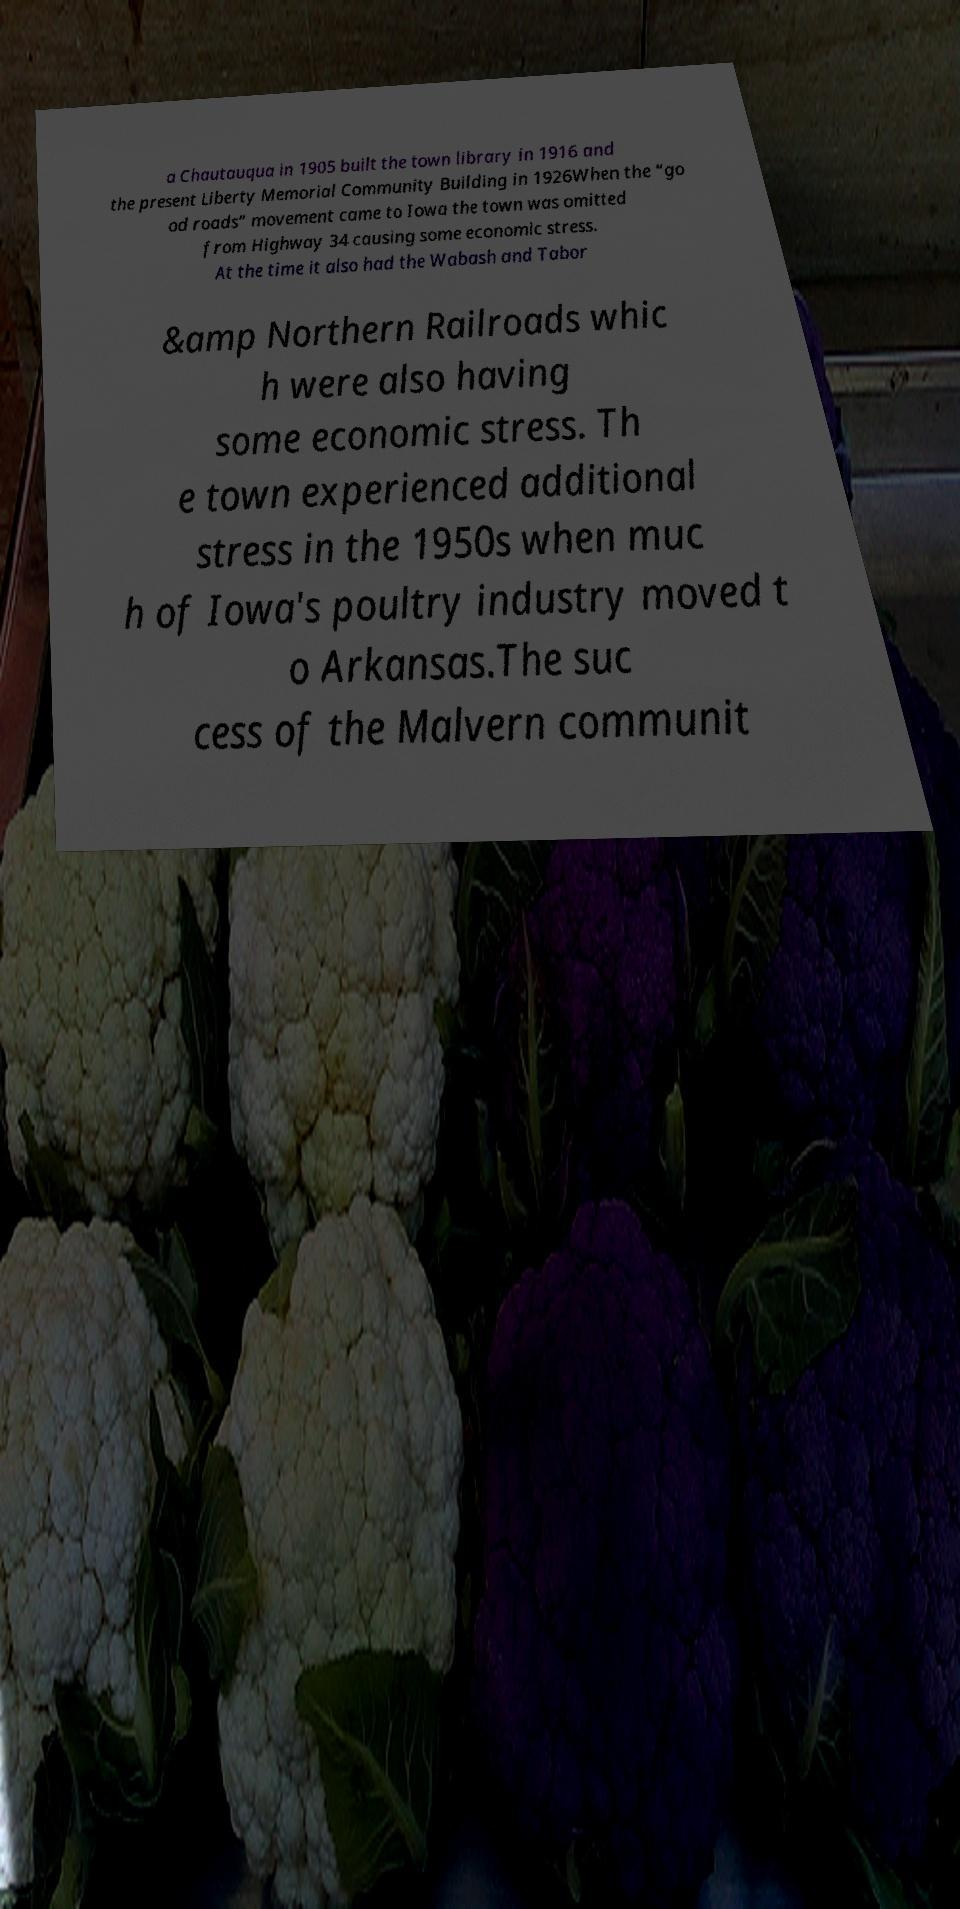Can you read and provide the text displayed in the image?This photo seems to have some interesting text. Can you extract and type it out for me? a Chautauqua in 1905 built the town library in 1916 and the present Liberty Memorial Community Building in 1926When the “go od roads” movement came to Iowa the town was omitted from Highway 34 causing some economic stress. At the time it also had the Wabash and Tabor &amp Northern Railroads whic h were also having some economic stress. Th e town experienced additional stress in the 1950s when muc h of Iowa's poultry industry moved t o Arkansas.The suc cess of the Malvern communit 